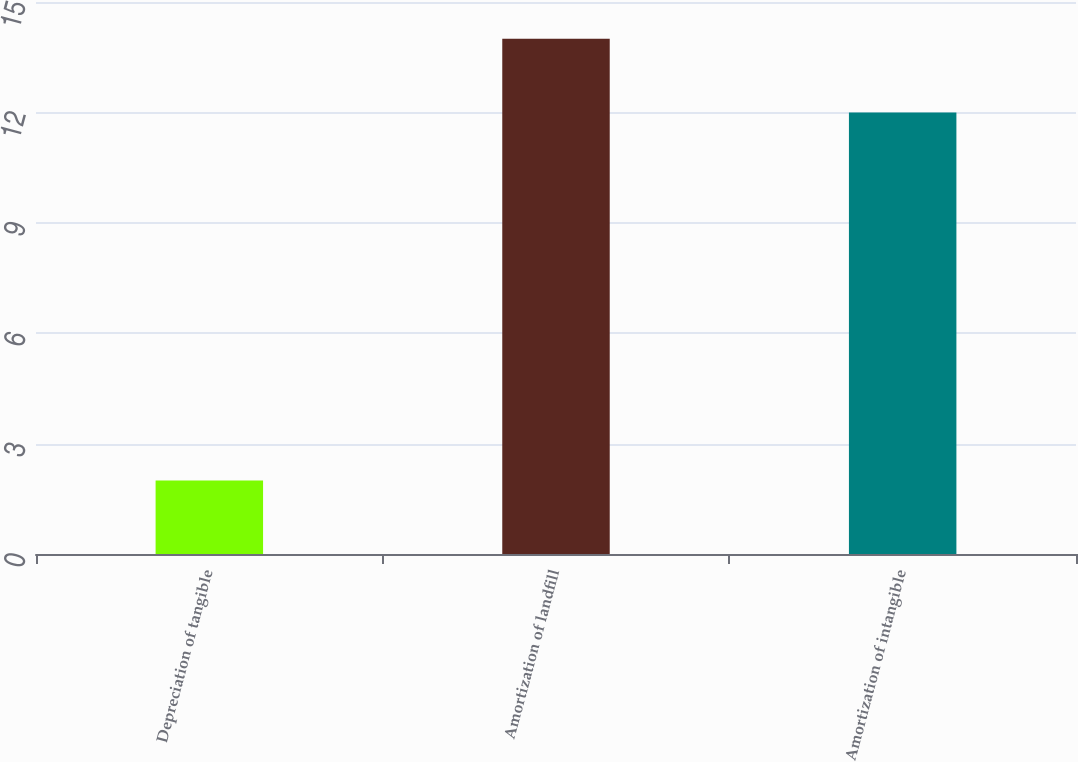<chart> <loc_0><loc_0><loc_500><loc_500><bar_chart><fcel>Depreciation of tangible<fcel>Amortization of landfill<fcel>Amortization of intangible<nl><fcel>2<fcel>14<fcel>12<nl></chart> 